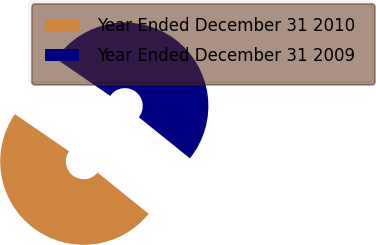Convert chart to OTSL. <chart><loc_0><loc_0><loc_500><loc_500><pie_chart><fcel>Year Ended December 31 2010<fcel>Year Ended December 31 2009<nl><fcel>48.78%<fcel>51.22%<nl></chart> 